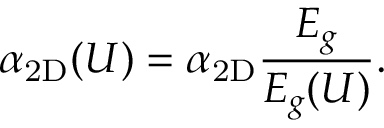Convert formula to latex. <formula><loc_0><loc_0><loc_500><loc_500>\alpha _ { 2 D } ( U ) = \alpha _ { 2 D } \frac { E _ { g } } { E _ { g } ( U ) } .</formula> 